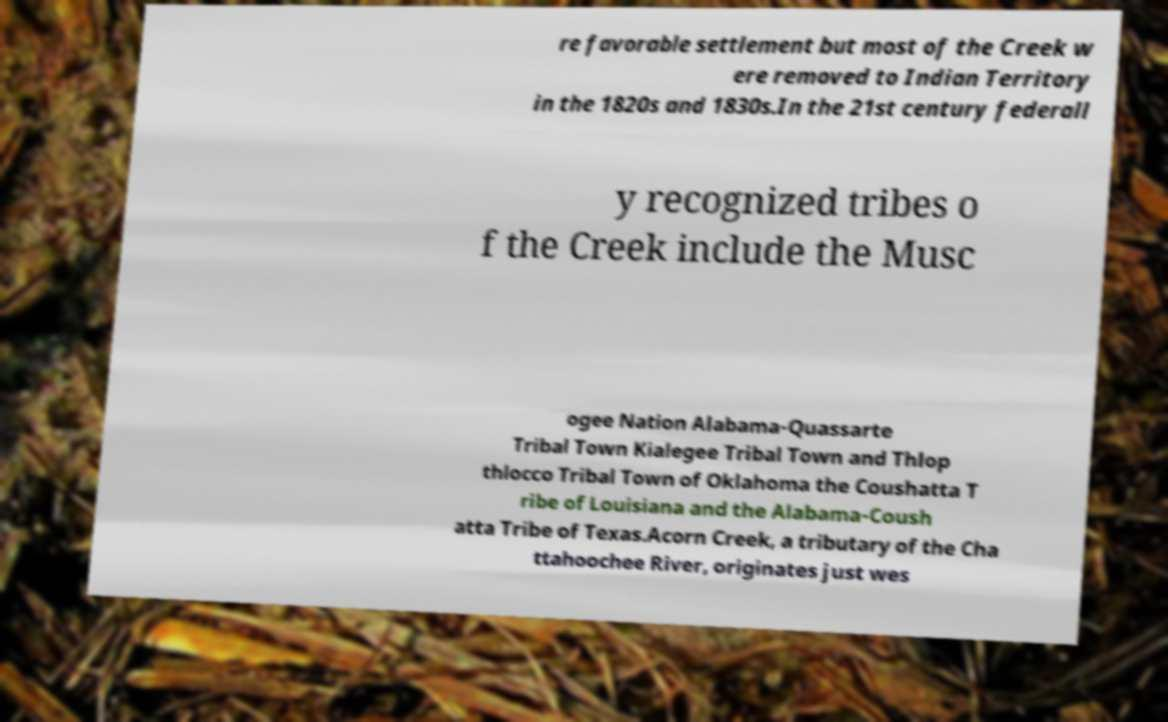Can you read and provide the text displayed in the image?This photo seems to have some interesting text. Can you extract and type it out for me? re favorable settlement but most of the Creek w ere removed to Indian Territory in the 1820s and 1830s.In the 21st century federall y recognized tribes o f the Creek include the Musc ogee Nation Alabama-Quassarte Tribal Town Kialegee Tribal Town and Thlop thlocco Tribal Town of Oklahoma the Coushatta T ribe of Louisiana and the Alabama-Coush atta Tribe of Texas.Acorn Creek, a tributary of the Cha ttahoochee River, originates just wes 